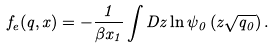<formula> <loc_0><loc_0><loc_500><loc_500>f _ { e } ( { q } , { x } ) = - \frac { 1 } { \beta x _ { 1 } } \int D z \ln \psi _ { 0 } \left ( z \sqrt { q _ { 0 } } \right ) .</formula> 